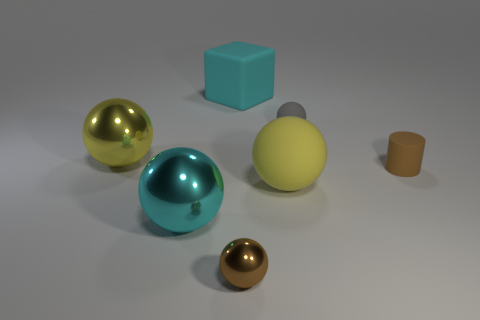Subtract all brown metal balls. How many balls are left? 4 Subtract all cyan cylinders. How many yellow balls are left? 2 Add 2 small shiny balls. How many objects exist? 9 Subtract all yellow balls. How many balls are left? 3 Subtract all cyan spheres. Subtract all green blocks. How many spheres are left? 4 Subtract all rubber cubes. Subtract all big objects. How many objects are left? 2 Add 7 large cubes. How many large cubes are left? 8 Add 2 rubber cubes. How many rubber cubes exist? 3 Subtract 0 red blocks. How many objects are left? 7 Subtract all cubes. How many objects are left? 6 